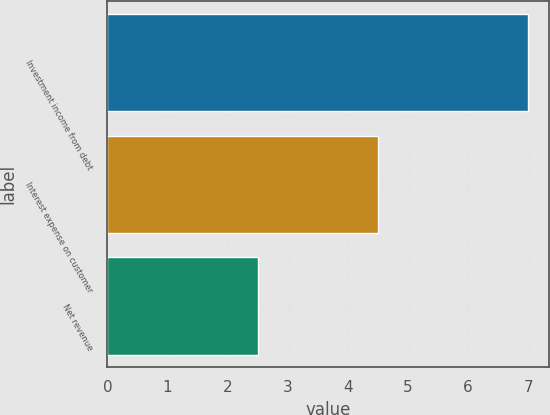Convert chart. <chart><loc_0><loc_0><loc_500><loc_500><bar_chart><fcel>Investment income from debt<fcel>Interest expense on customer<fcel>Net revenue<nl><fcel>7<fcel>4.5<fcel>2.5<nl></chart> 